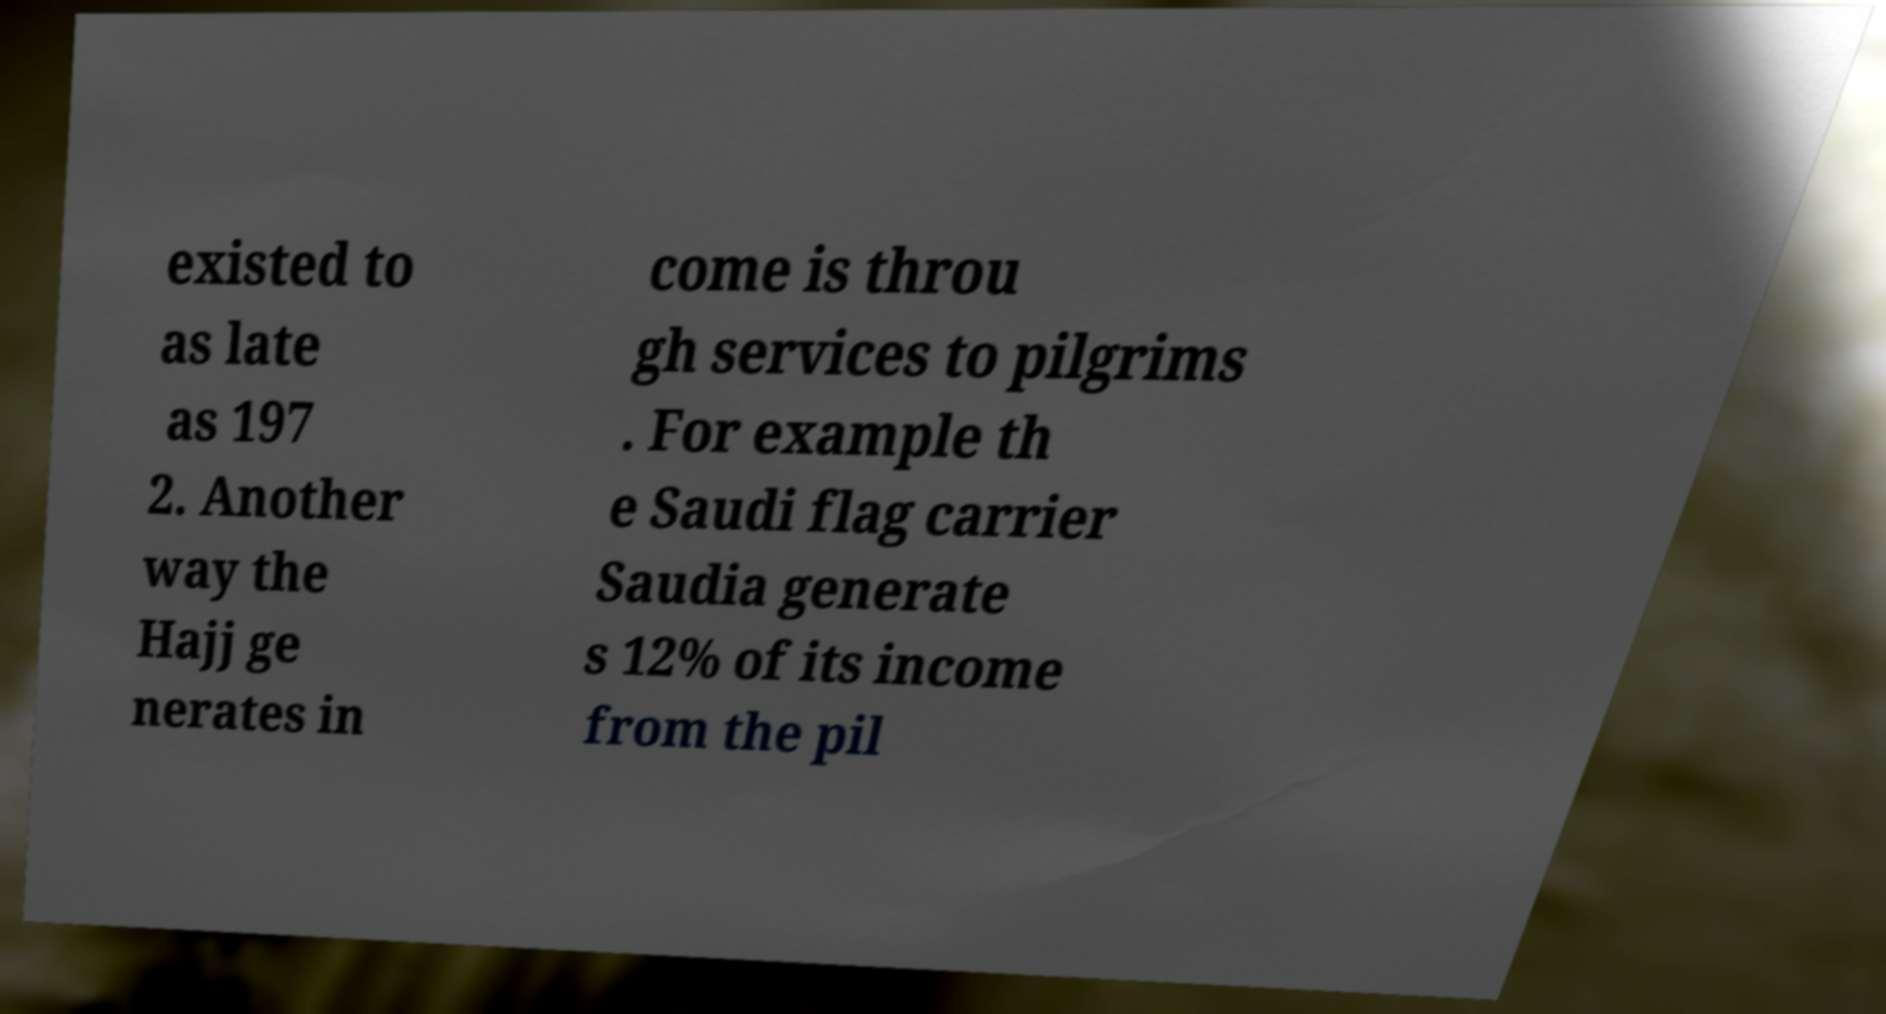Can you read and provide the text displayed in the image?This photo seems to have some interesting text. Can you extract and type it out for me? existed to as late as 197 2. Another way the Hajj ge nerates in come is throu gh services to pilgrims . For example th e Saudi flag carrier Saudia generate s 12% of its income from the pil 